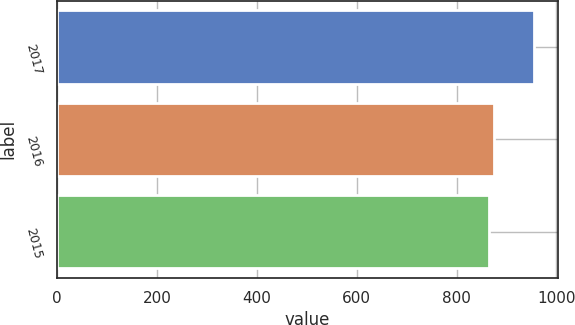Convert chart. <chart><loc_0><loc_0><loc_500><loc_500><bar_chart><fcel>2017<fcel>2016<fcel>2015<nl><fcel>955<fcel>874<fcel>864<nl></chart> 